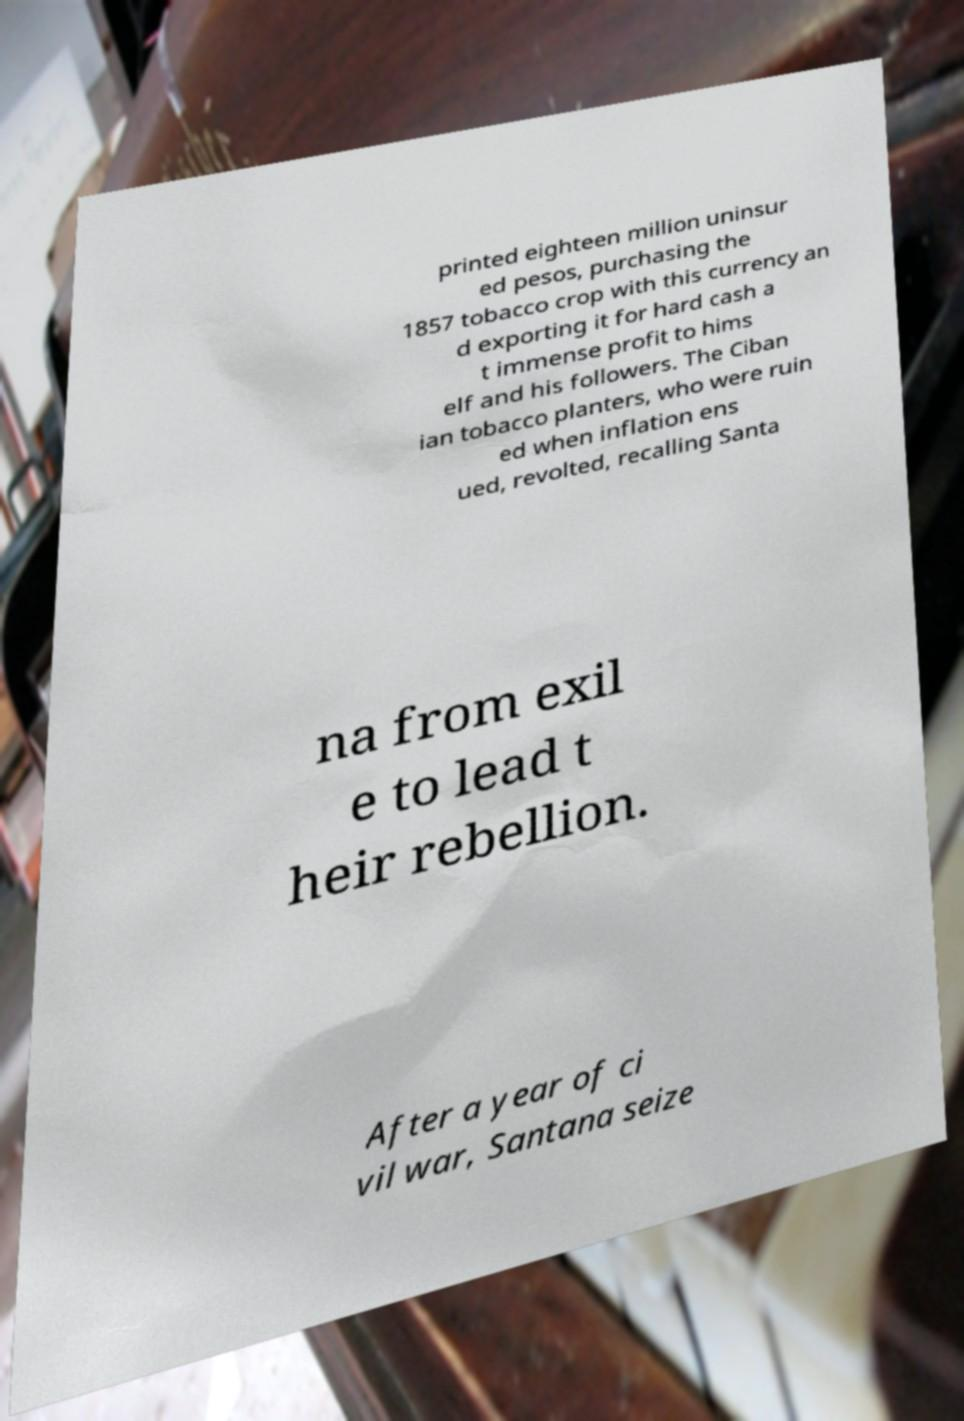For documentation purposes, I need the text within this image transcribed. Could you provide that? printed eighteen million uninsur ed pesos, purchasing the 1857 tobacco crop with this currency an d exporting it for hard cash a t immense profit to hims elf and his followers. The Ciban ian tobacco planters, who were ruin ed when inflation ens ued, revolted, recalling Santa na from exil e to lead t heir rebellion. After a year of ci vil war, Santana seize 